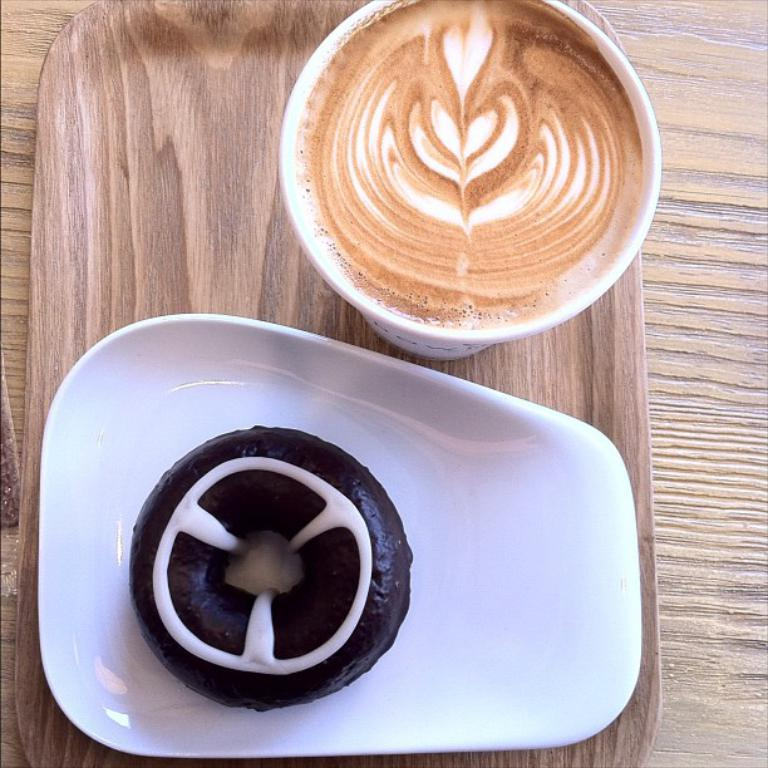What piece of furniture is present in the image? There is a table in the image. What is placed on the table? There is a tray on the table. What is on the tray? There is a cup of coffee and a doughnut on a plate on the tray. What type of sock is being used to stir the eggnog in the image? There is no eggnog or sock present in the image. 